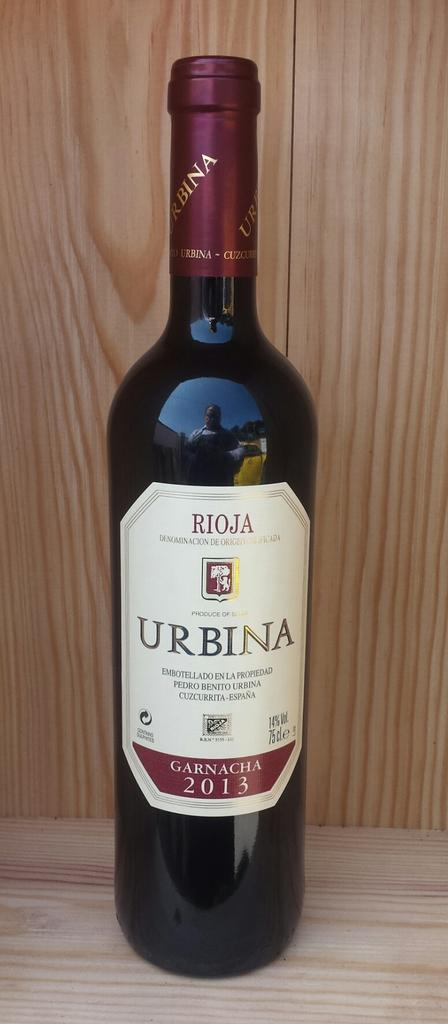What object can be seen in the image? There is a bottle in the image. On what surface is the bottle placed? The bottle is on a wooden surface. What colors are present on the bottle? The bottle has black and maroon colors. What can be seen in the background of the image? There is a wooden wall in the background of the image. What color is the wooden wall? The wooden wall is in brown color. How many dolls are sitting on the shirt in the image? There are no dolls or shirts present in the image. 